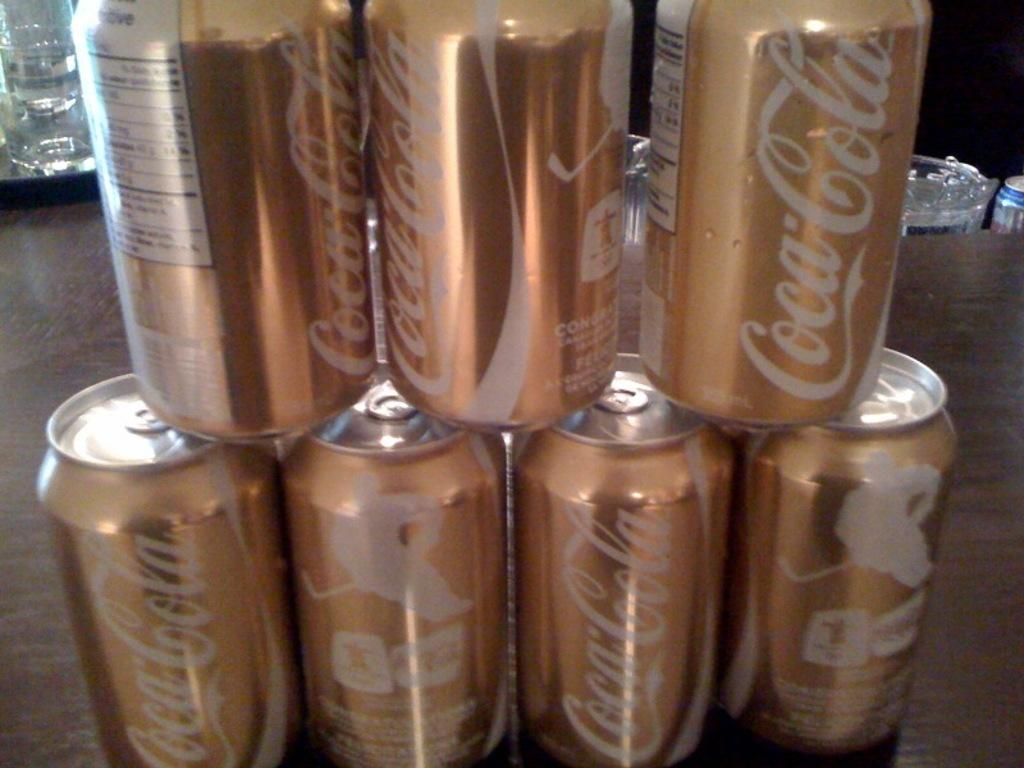Provide a one-sentence caption for the provided image. The coca cola cans have a gold tint to them. 